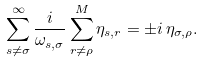Convert formula to latex. <formula><loc_0><loc_0><loc_500><loc_500>\sum _ { s \neq \sigma } ^ { \infty } \frac { i } { \omega _ { s , \sigma } } \sum _ { r \neq \rho } ^ { M } \eta _ { s , r } = \pm i \, \eta _ { \sigma , \rho } .</formula> 